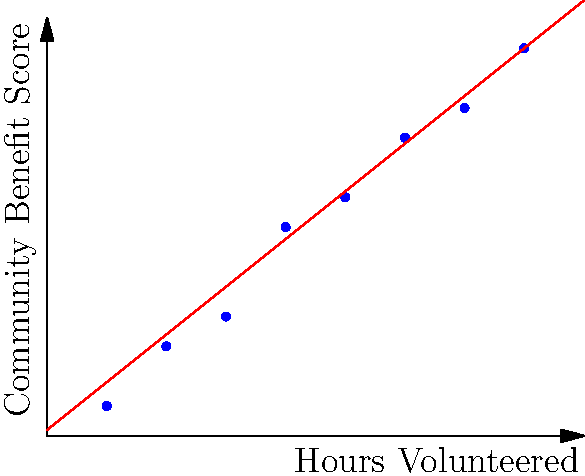Based on the scatter plot showing the relationship between volunteer hours and community benefit score, what is the approximate increase in community benefit score for every 2 additional hours of volunteer work? To solve this problem, we need to follow these steps:

1. Observe the trend line (red line) in the scatter plot, which represents the general relationship between hours volunteered and community benefit score.

2. Identify two points on the trend line to calculate the rate of change. Let's use:
   Point 1: (0, 0.2) - where the line intersects the y-axis
   Point 2: (18, 14.6) - the endpoint of the line

3. Calculate the slope of the line using the formula:
   $$ \text{slope} = \frac{y_2 - y_1}{x_2 - x_1} = \frac{14.6 - 0.2}{18 - 0} = \frac{14.4}{18} = 0.8 $$

4. The slope represents the increase in community benefit score per hour of volunteer work.

5. To find the increase for 2 hours, multiply the slope by 2:
   $$ 0.8 \times 2 = 1.6 $$

Therefore, for every 2 additional hours of volunteer work, the community benefit score increases by approximately 1.6 points.
Answer: 1.6 points 